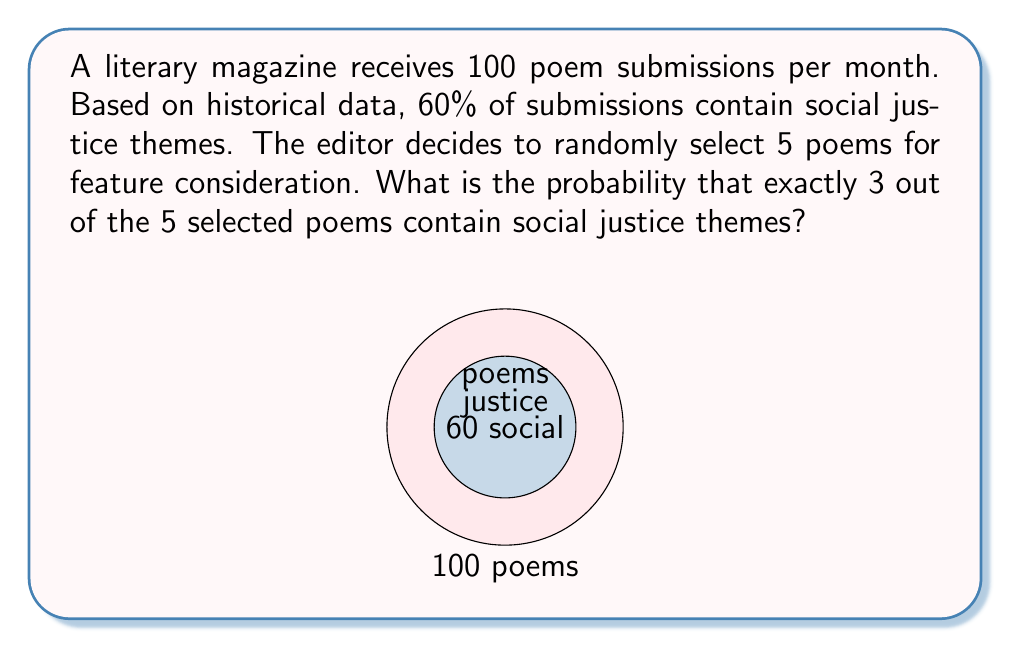Can you solve this math problem? To solve this problem, we can use the Binomial probability distribution:

1) Let X be the number of poems with social justice themes in the 5 selected.
2) X follows a Binomial distribution with n = 5 (number of trials) and p = 0.60 (probability of success).
3) We want to find P(X = 3).

The probability mass function for a Binomial distribution is:

$$ P(X = k) = \binom{n}{k} p^k (1-p)^{n-k} $$

Where:
- n is the number of trials
- k is the number of successes
- p is the probability of success on each trial

Substituting our values:

$$ P(X = 3) = \binom{5}{3} (0.60)^3 (1-0.60)^{5-3} $$

$$ = \binom{5}{3} (0.60)^3 (0.40)^2 $$

$$ = 10 \times 0.216 \times 0.16 $$

$$ = 0.3456 $$

Therefore, the probability of exactly 3 out of 5 randomly selected poems containing social justice themes is approximately 0.3456 or 34.56%.
Answer: 0.3456 